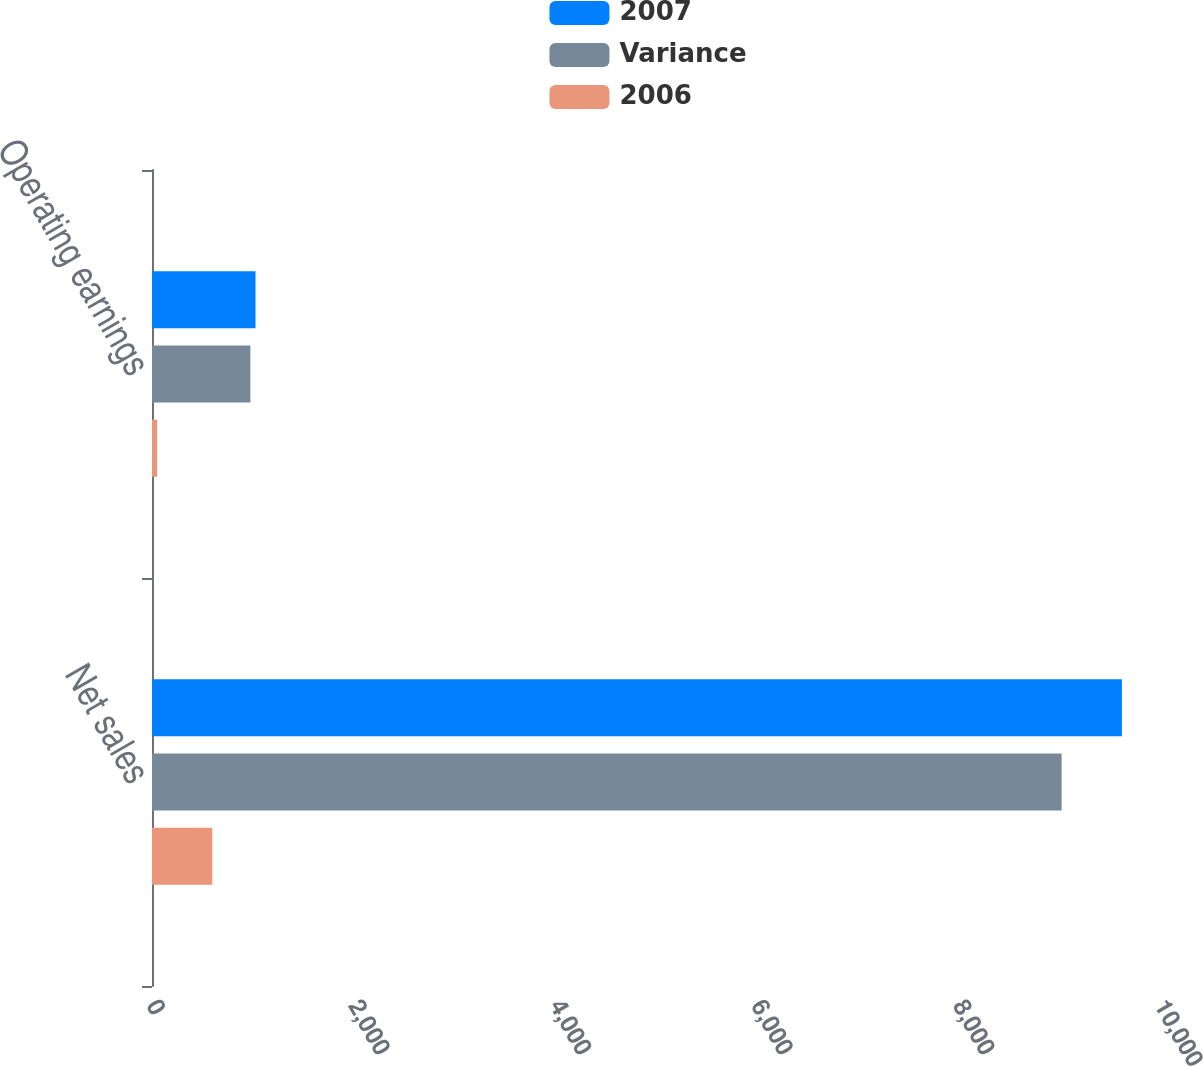Convert chart to OTSL. <chart><loc_0><loc_0><loc_500><loc_500><stacked_bar_chart><ecel><fcel>Net sales<fcel>Operating earnings<nl><fcel>2007<fcel>9622<fcel>1027<nl><fcel>Variance<fcel>9024<fcel>976<nl><fcel>2006<fcel>598<fcel>51<nl></chart> 